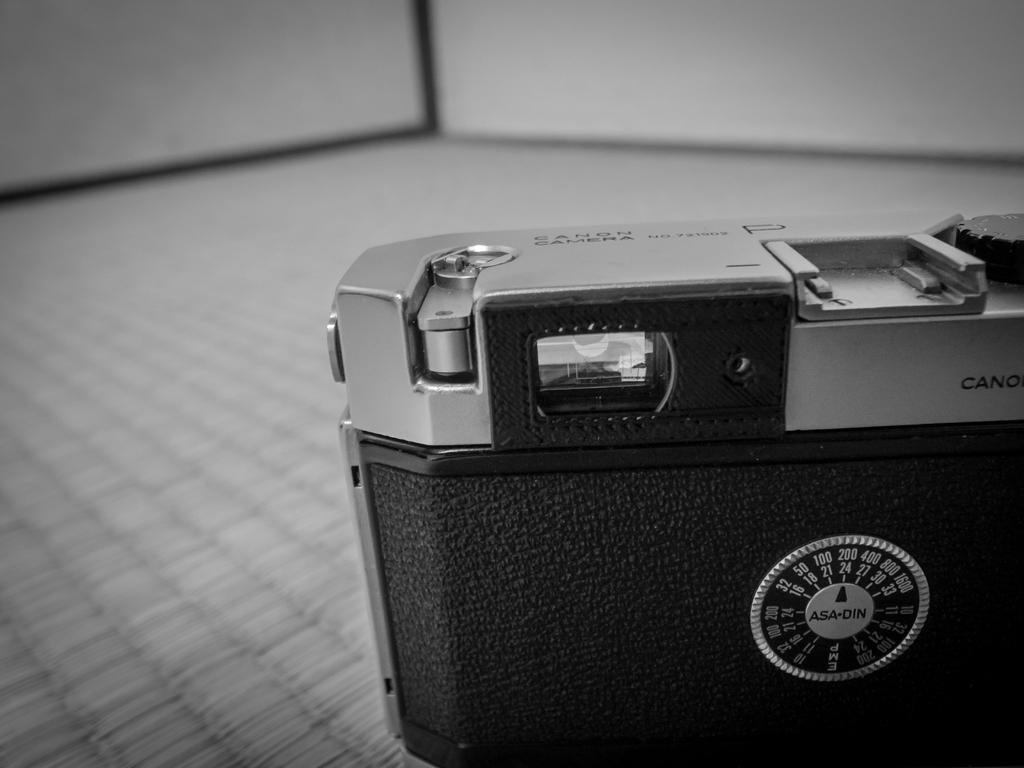What object is the main focus of the image? There is a camera in the image. What type of bean is being discussed in the image? There is no bean or discussion present in the image; it only features a camera. What type of creature is interacting with the camera in the image? There is no creature present in the image; it only features a camera. 